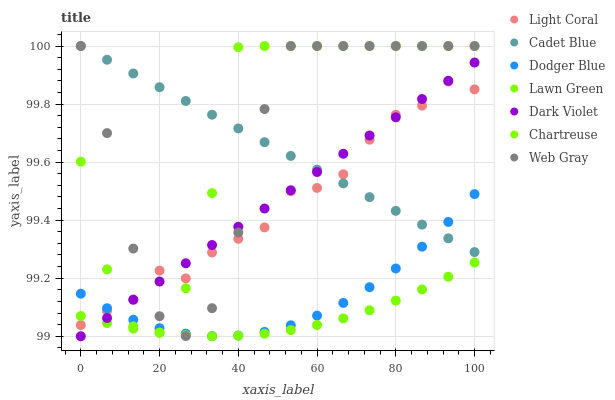Does Lawn Green have the minimum area under the curve?
Answer yes or no. Yes. Does Chartreuse have the maximum area under the curve?
Answer yes or no. Yes. Does Cadet Blue have the minimum area under the curve?
Answer yes or no. No. Does Cadet Blue have the maximum area under the curve?
Answer yes or no. No. Is Dark Violet the smoothest?
Answer yes or no. Yes. Is Chartreuse the roughest?
Answer yes or no. Yes. Is Cadet Blue the smoothest?
Answer yes or no. No. Is Cadet Blue the roughest?
Answer yes or no. No. Does Dark Violet have the lowest value?
Answer yes or no. Yes. Does Cadet Blue have the lowest value?
Answer yes or no. No. Does Web Gray have the highest value?
Answer yes or no. Yes. Does Dark Violet have the highest value?
Answer yes or no. No. Is Lawn Green less than Dodger Blue?
Answer yes or no. Yes. Is Cadet Blue greater than Lawn Green?
Answer yes or no. Yes. Does Dodger Blue intersect Light Coral?
Answer yes or no. Yes. Is Dodger Blue less than Light Coral?
Answer yes or no. No. Is Dodger Blue greater than Light Coral?
Answer yes or no. No. Does Lawn Green intersect Dodger Blue?
Answer yes or no. No. 